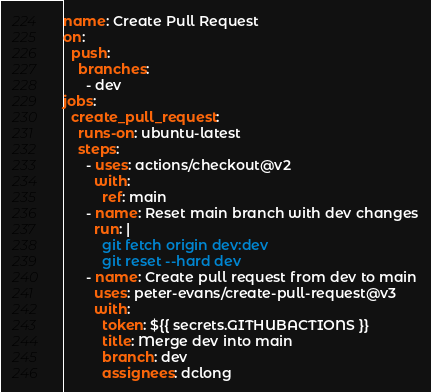Convert code to text. <code><loc_0><loc_0><loc_500><loc_500><_YAML_>name: Create Pull Request
on:
  push:
    branches:
      - dev
jobs:
  create_pull_request:
    runs-on: ubuntu-latest
    steps:
      - uses: actions/checkout@v2
        with:
          ref: main
      - name: Reset main branch with dev changes
        run: |
          git fetch origin dev:dev
          git reset --hard dev
      - name: Create pull request from dev to main
        uses: peter-evans/create-pull-request@v3
        with:
          token: ${{ secrets.GITHUBACTIONS }} 
          title: Merge dev into main
          branch: dev
          assignees: dclong  
</code> 